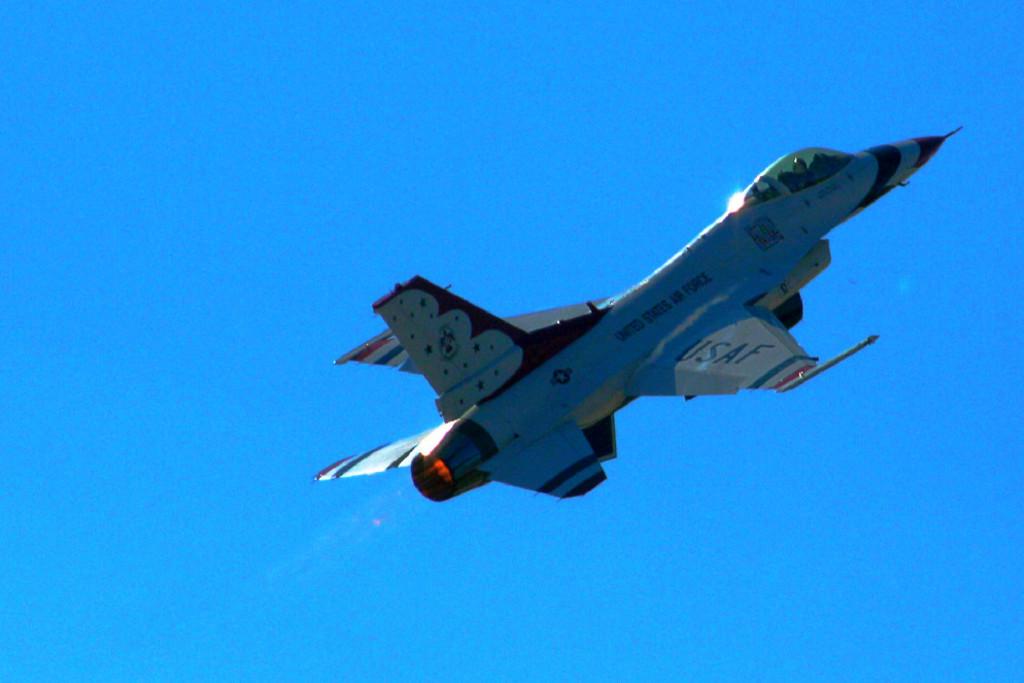What does the airplane say?
Your answer should be compact. Usaf. What branch of service is this?
Your answer should be very brief. Air force. 